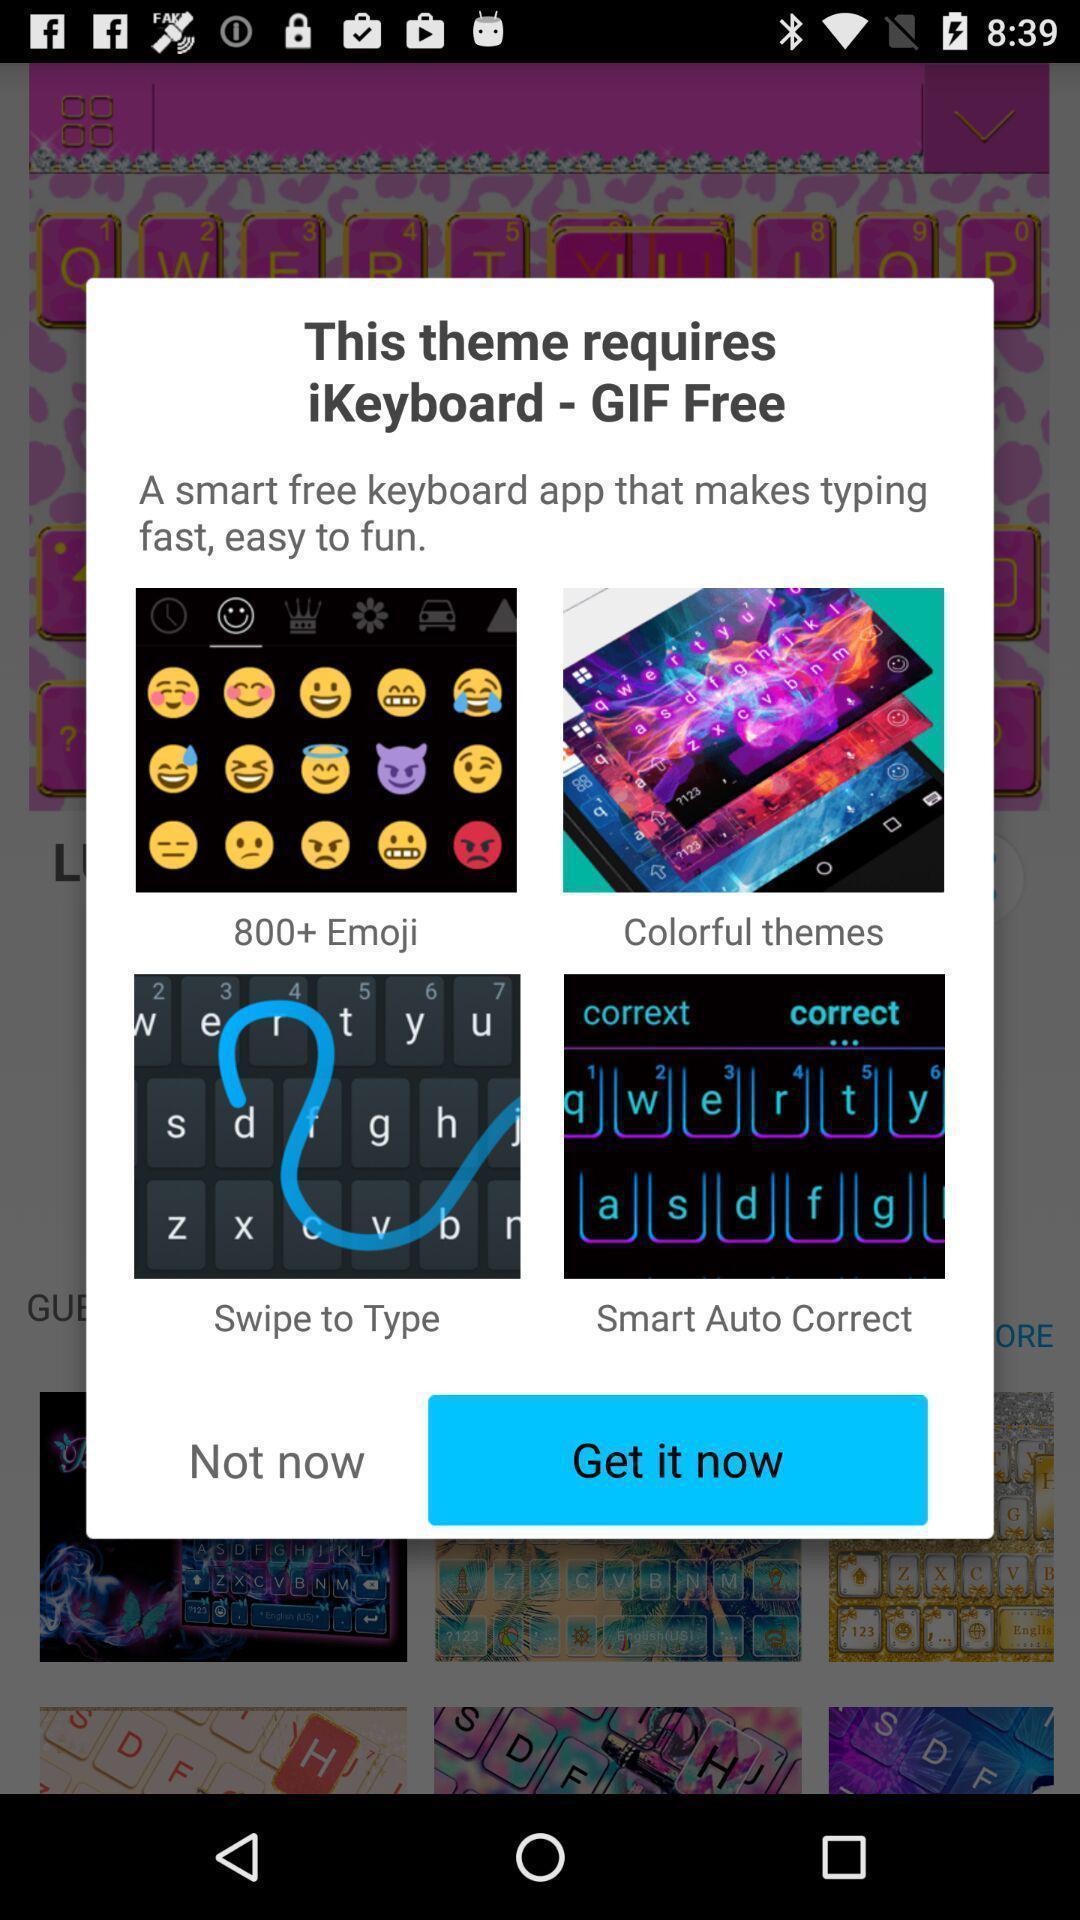What details can you identify in this image? Pop-up shows to get a keyboard app. 